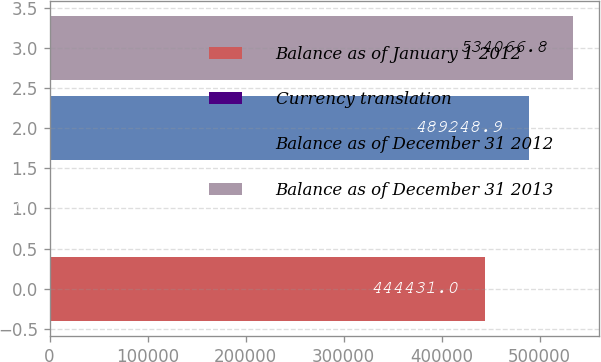Convert chart. <chart><loc_0><loc_0><loc_500><loc_500><bar_chart><fcel>Balance as of January 1 2012<fcel>Currency translation<fcel>Balance as of December 31 2012<fcel>Balance as of December 31 2013<nl><fcel>444431<fcel>1317<fcel>489249<fcel>534067<nl></chart> 